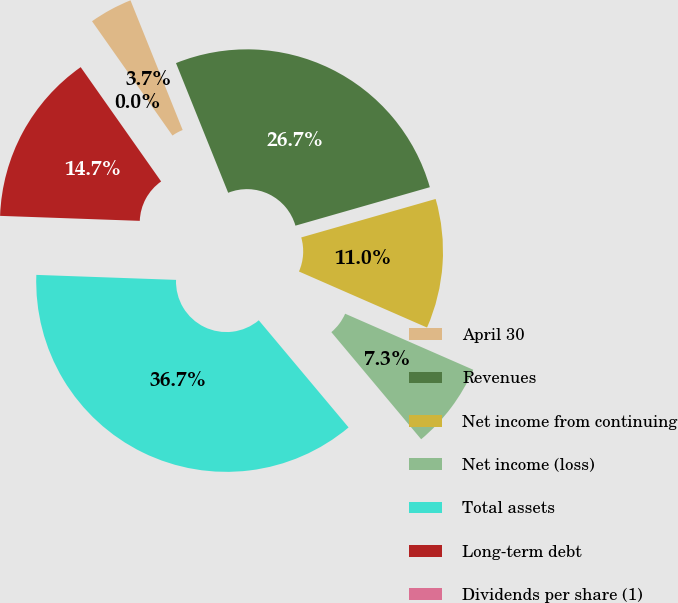Convert chart to OTSL. <chart><loc_0><loc_0><loc_500><loc_500><pie_chart><fcel>April 30<fcel>Revenues<fcel>Net income from continuing<fcel>Net income (loss)<fcel>Total assets<fcel>Long-term debt<fcel>Dividends per share (1)<nl><fcel>3.67%<fcel>26.65%<fcel>11.0%<fcel>7.33%<fcel>36.67%<fcel>14.67%<fcel>0.0%<nl></chart> 